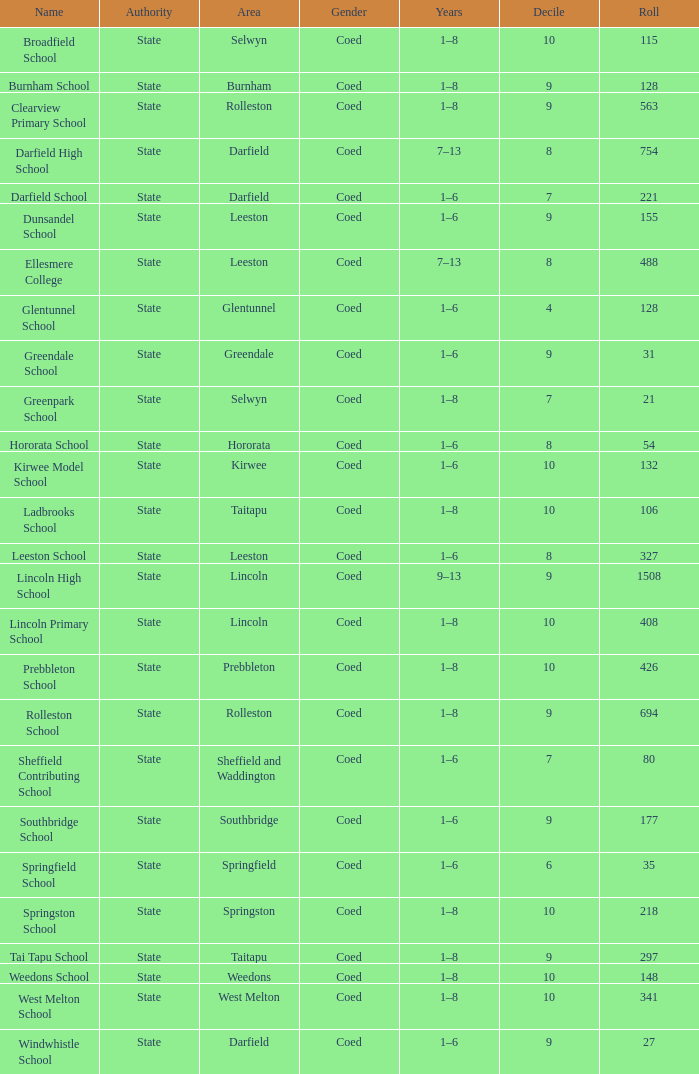How many deciles have Years of 9–13? 1.0. 